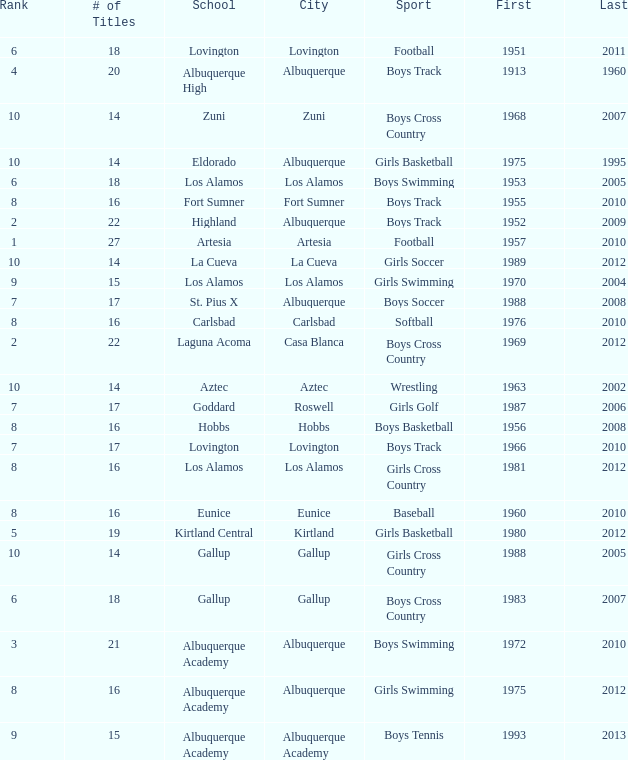What city is the School, Highland, in that ranks less than 8 and had its first title before 1980 and its last title later than 1960? Albuquerque. 